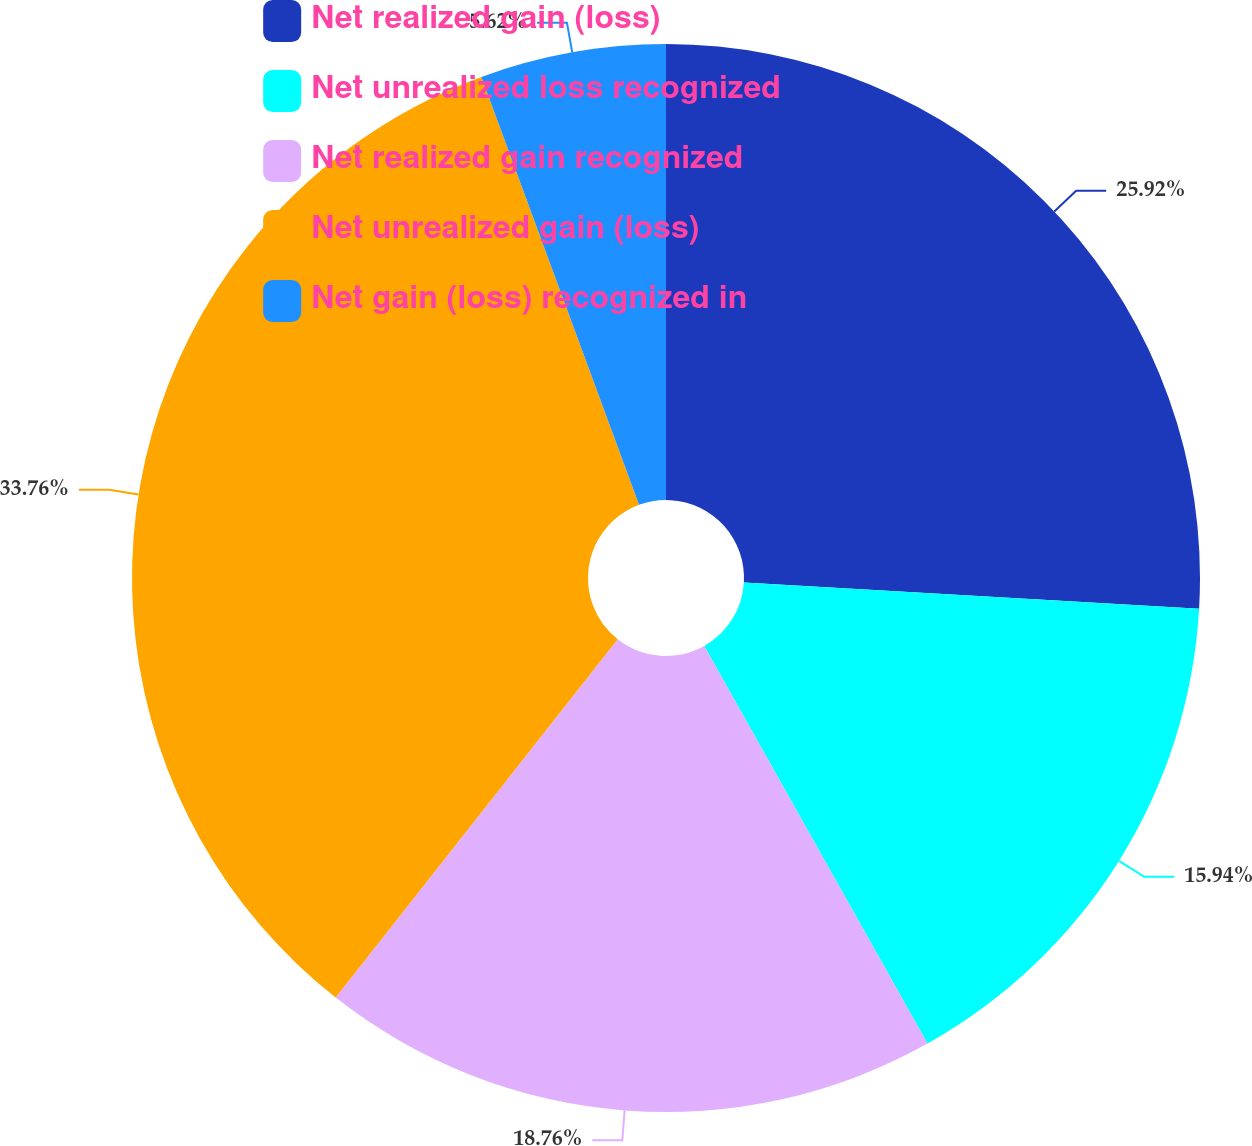<chart> <loc_0><loc_0><loc_500><loc_500><pie_chart><fcel>Net realized gain (loss)<fcel>Net unrealized loss recognized<fcel>Net realized gain recognized<fcel>Net unrealized gain (loss)<fcel>Net gain (loss) recognized in<nl><fcel>25.92%<fcel>15.94%<fcel>18.76%<fcel>33.77%<fcel>5.62%<nl></chart> 